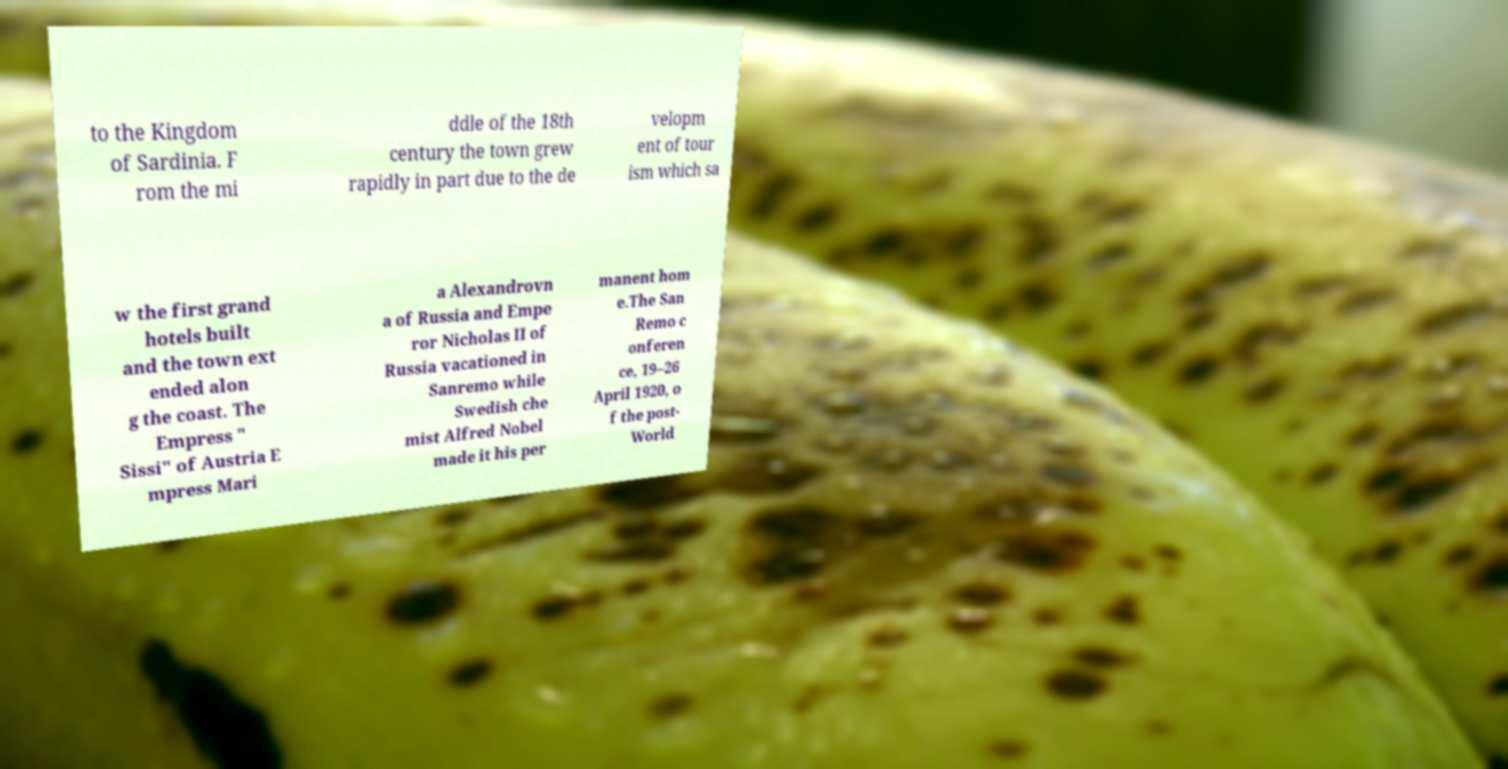Could you assist in decoding the text presented in this image and type it out clearly? to the Kingdom of Sardinia. F rom the mi ddle of the 18th century the town grew rapidly in part due to the de velopm ent of tour ism which sa w the first grand hotels built and the town ext ended alon g the coast. The Empress " Sissi" of Austria E mpress Mari a Alexandrovn a of Russia and Empe ror Nicholas II of Russia vacationed in Sanremo while Swedish che mist Alfred Nobel made it his per manent hom e.The San Remo c onferen ce, 19–26 April 1920, o f the post- World 